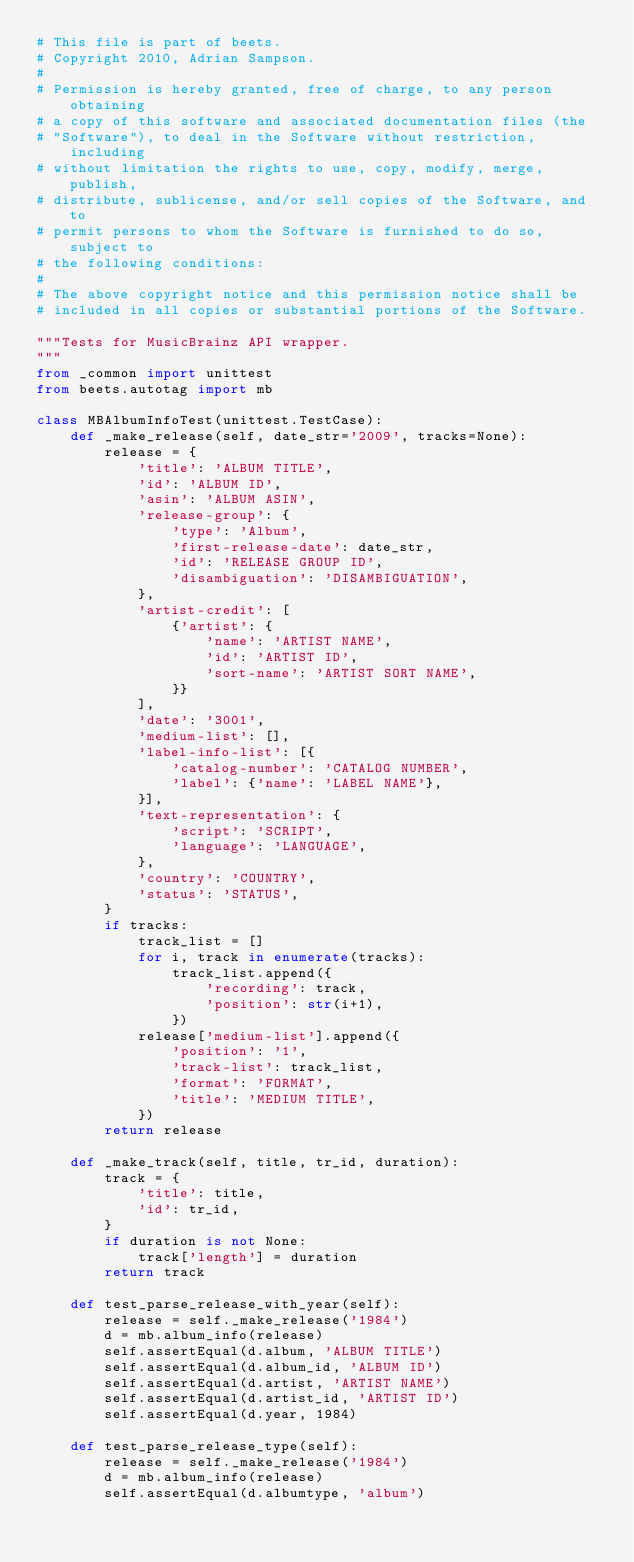<code> <loc_0><loc_0><loc_500><loc_500><_Python_># This file is part of beets.
# Copyright 2010, Adrian Sampson.
#
# Permission is hereby granted, free of charge, to any person obtaining
# a copy of this software and associated documentation files (the
# "Software"), to deal in the Software without restriction, including
# without limitation the rights to use, copy, modify, merge, publish,
# distribute, sublicense, and/or sell copies of the Software, and to
# permit persons to whom the Software is furnished to do so, subject to
# the following conditions:
#
# The above copyright notice and this permission notice shall be
# included in all copies or substantial portions of the Software.

"""Tests for MusicBrainz API wrapper.
"""
from _common import unittest
from beets.autotag import mb

class MBAlbumInfoTest(unittest.TestCase):
    def _make_release(self, date_str='2009', tracks=None):
        release = {
            'title': 'ALBUM TITLE',
            'id': 'ALBUM ID',
            'asin': 'ALBUM ASIN',
            'release-group': {
                'type': 'Album',
                'first-release-date': date_str,
                'id': 'RELEASE GROUP ID',
                'disambiguation': 'DISAMBIGUATION',
            },
            'artist-credit': [
                {'artist': {
                    'name': 'ARTIST NAME',
                    'id': 'ARTIST ID',
                    'sort-name': 'ARTIST SORT NAME',
                }}
            ],
            'date': '3001',
            'medium-list': [],
            'label-info-list': [{
                'catalog-number': 'CATALOG NUMBER',
                'label': {'name': 'LABEL NAME'},
            }],
            'text-representation': {
                'script': 'SCRIPT',
                'language': 'LANGUAGE',
            },
            'country': 'COUNTRY',
            'status': 'STATUS',
        }
        if tracks:
            track_list = []
            for i, track in enumerate(tracks):
                track_list.append({
                    'recording': track,
                    'position': str(i+1),
                })
            release['medium-list'].append({
                'position': '1',
                'track-list': track_list,
                'format': 'FORMAT',
                'title': 'MEDIUM TITLE',
            })
        return release

    def _make_track(self, title, tr_id, duration):
        track = {
            'title': title,
            'id': tr_id,
        }
        if duration is not None:
            track['length'] = duration
        return track

    def test_parse_release_with_year(self):
        release = self._make_release('1984')
        d = mb.album_info(release)
        self.assertEqual(d.album, 'ALBUM TITLE')
        self.assertEqual(d.album_id, 'ALBUM ID')
        self.assertEqual(d.artist, 'ARTIST NAME')
        self.assertEqual(d.artist_id, 'ARTIST ID')
        self.assertEqual(d.year, 1984)

    def test_parse_release_type(self):
        release = self._make_release('1984')
        d = mb.album_info(release)
        self.assertEqual(d.albumtype, 'album')
</code> 